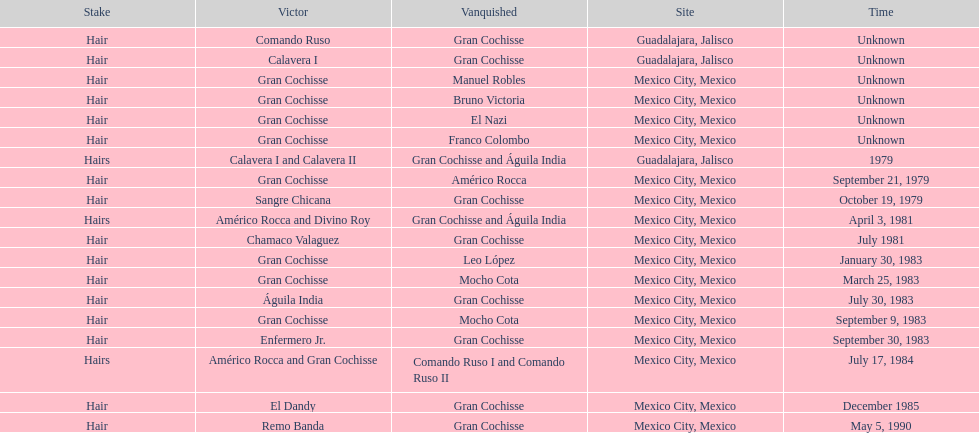When was the first match of gran chochisse with a fully recorded date held? September 21, 1979. 